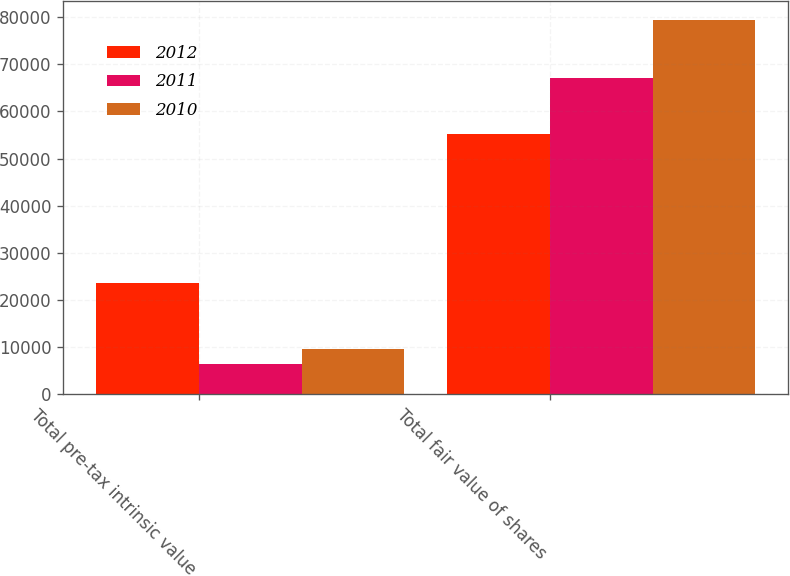<chart> <loc_0><loc_0><loc_500><loc_500><stacked_bar_chart><ecel><fcel>Total pre-tax intrinsic value<fcel>Total fair value of shares<nl><fcel>2012<fcel>23678<fcel>55186<nl><fcel>2011<fcel>6429<fcel>67076<nl><fcel>2010<fcel>9567<fcel>79434<nl></chart> 